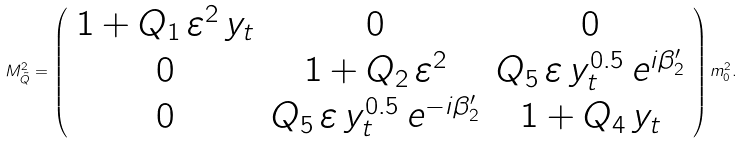<formula> <loc_0><loc_0><loc_500><loc_500>M _ { \tilde { Q } } ^ { 2 } = \left ( \begin{array} { c c c } 1 + Q _ { 1 } \, \varepsilon ^ { 2 } \, y _ { t } & 0 & 0 \\ 0 & 1 + Q _ { 2 } \, \varepsilon ^ { 2 } & Q _ { 5 } \, \varepsilon \, y _ { t } ^ { 0 . 5 } \, e ^ { i \beta ^ { \prime } _ { 2 } } \\ 0 & Q _ { 5 } \, \varepsilon \, y _ { t } ^ { 0 . 5 } \, e ^ { - i \beta ^ { \prime } _ { 2 } } & 1 + Q _ { 4 } \, y _ { t } \end{array} \right ) m _ { 0 } ^ { 2 } .</formula> 